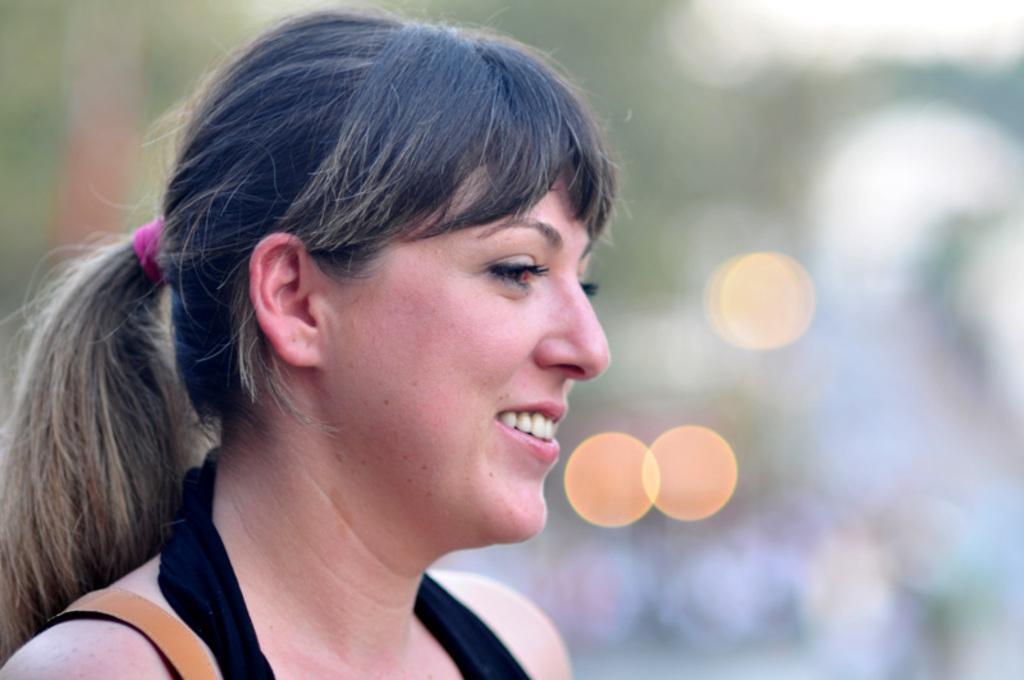In one or two sentences, can you explain what this image depicts? This picture shows a woman with a smile on her face. 